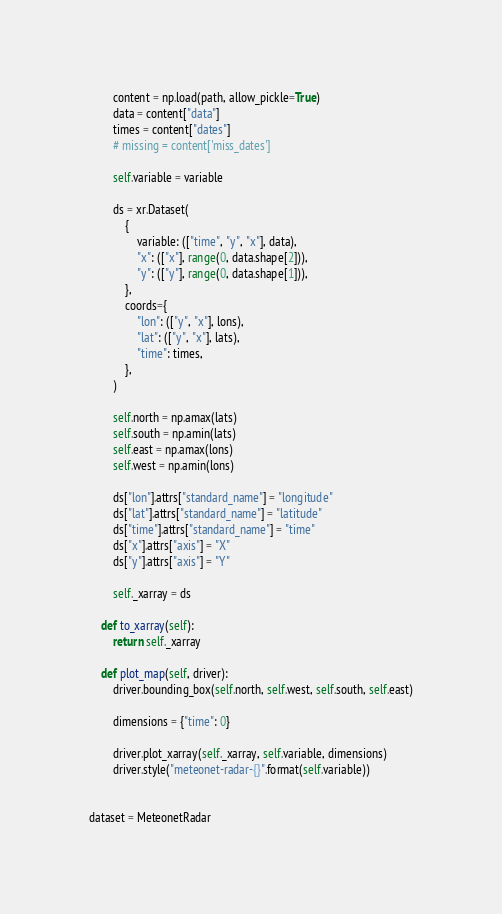<code> <loc_0><loc_0><loc_500><loc_500><_Python_>        content = np.load(path, allow_pickle=True)
        data = content["data"]
        times = content["dates"]
        # missing = content['miss_dates']

        self.variable = variable

        ds = xr.Dataset(
            {
                variable: (["time", "y", "x"], data),
                "x": (["x"], range(0, data.shape[2])),
                "y": (["y"], range(0, data.shape[1])),
            },
            coords={
                "lon": (["y", "x"], lons),
                "lat": (["y", "x"], lats),
                "time": times,
            },
        )

        self.north = np.amax(lats)
        self.south = np.amin(lats)
        self.east = np.amax(lons)
        self.west = np.amin(lons)

        ds["lon"].attrs["standard_name"] = "longitude"
        ds["lat"].attrs["standard_name"] = "latitude"
        ds["time"].attrs["standard_name"] = "time"
        ds["x"].attrs["axis"] = "X"
        ds["y"].attrs["axis"] = "Y"

        self._xarray = ds

    def to_xarray(self):
        return self._xarray

    def plot_map(self, driver):
        driver.bounding_box(self.north, self.west, self.south, self.east)

        dimensions = {"time": 0}

        driver.plot_xarray(self._xarray, self.variable, dimensions)
        driver.style("meteonet-radar-{}".format(self.variable))


dataset = MeteonetRadar
</code> 